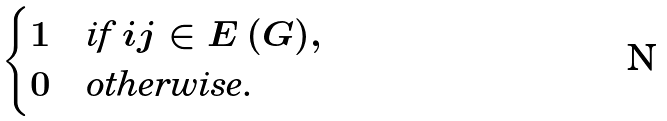<formula> <loc_0><loc_0><loc_500><loc_500>\begin{cases} 1 & \text {if $ij\in E\left( G\right)$} , \\ 0 & \text {otherwise.} \end{cases}</formula> 